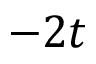Convert formula to latex. <formula><loc_0><loc_0><loc_500><loc_500>- 2 t</formula> 